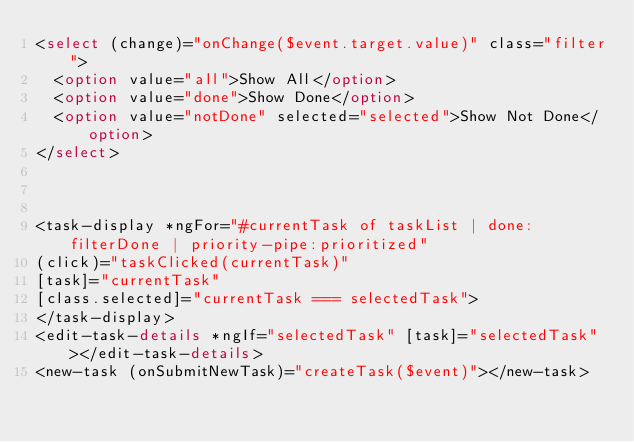Convert code to text. <code><loc_0><loc_0><loc_500><loc_500><_HTML_><select (change)="onChange($event.target.value)" class="filter">
  <option value="all">Show All</option>
  <option value="done">Show Done</option>
  <option value="notDone" selected="selected">Show Not Done</option>
</select>



<task-display *ngFor="#currentTask of taskList | done:filterDone | priority-pipe:prioritized"
(click)="taskClicked(currentTask)"
[task]="currentTask"
[class.selected]="currentTask === selectedTask">
</task-display>
<edit-task-details *ngIf="selectedTask" [task]="selectedTask"></edit-task-details>
<new-task (onSubmitNewTask)="createTask($event)"></new-task>
</code> 